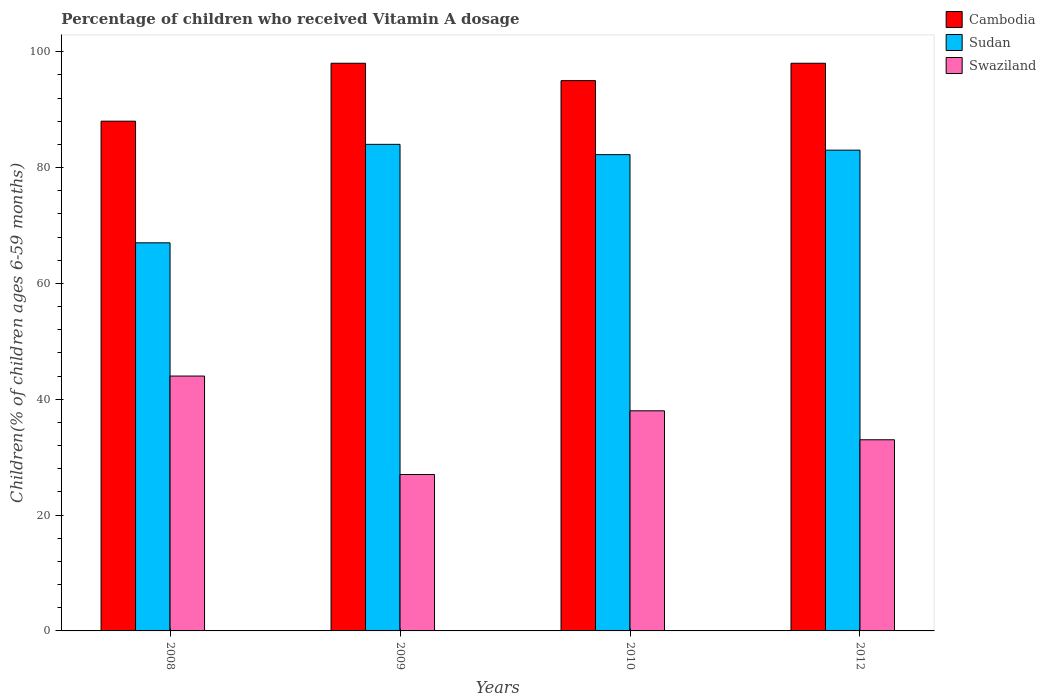How many groups of bars are there?
Keep it short and to the point. 4. Are the number of bars per tick equal to the number of legend labels?
Your answer should be compact. Yes. How many bars are there on the 4th tick from the left?
Make the answer very short. 3. What is the label of the 2nd group of bars from the left?
Offer a terse response. 2009. Across all years, what is the minimum percentage of children who received Vitamin A dosage in Sudan?
Provide a succinct answer. 67. What is the total percentage of children who received Vitamin A dosage in Cambodia in the graph?
Keep it short and to the point. 379. What is the difference between the percentage of children who received Vitamin A dosage in Sudan in 2010 and the percentage of children who received Vitamin A dosage in Cambodia in 2009?
Your response must be concise. -15.77. What is the average percentage of children who received Vitamin A dosage in Sudan per year?
Your answer should be compact. 79.06. In the year 2010, what is the difference between the percentage of children who received Vitamin A dosage in Cambodia and percentage of children who received Vitamin A dosage in Sudan?
Make the answer very short. 12.77. What is the ratio of the percentage of children who received Vitamin A dosage in Cambodia in 2008 to that in 2012?
Give a very brief answer. 0.9. Is the percentage of children who received Vitamin A dosage in Sudan in 2008 less than that in 2012?
Ensure brevity in your answer.  Yes. What is the difference between the highest and the second highest percentage of children who received Vitamin A dosage in Swaziland?
Offer a terse response. 6. Is the sum of the percentage of children who received Vitamin A dosage in Cambodia in 2008 and 2010 greater than the maximum percentage of children who received Vitamin A dosage in Swaziland across all years?
Ensure brevity in your answer.  Yes. What does the 3rd bar from the left in 2010 represents?
Ensure brevity in your answer.  Swaziland. What does the 2nd bar from the right in 2009 represents?
Your answer should be compact. Sudan. How many years are there in the graph?
Provide a short and direct response. 4. Are the values on the major ticks of Y-axis written in scientific E-notation?
Keep it short and to the point. No. What is the title of the graph?
Provide a short and direct response. Percentage of children who received Vitamin A dosage. Does "Least developed countries" appear as one of the legend labels in the graph?
Give a very brief answer. No. What is the label or title of the X-axis?
Your answer should be very brief. Years. What is the label or title of the Y-axis?
Provide a short and direct response. Children(% of children ages 6-59 months). What is the Children(% of children ages 6-59 months) in Cambodia in 2008?
Your answer should be very brief. 88. What is the Children(% of children ages 6-59 months) in Sudan in 2009?
Offer a terse response. 84. What is the Children(% of children ages 6-59 months) of Swaziland in 2009?
Make the answer very short. 27. What is the Children(% of children ages 6-59 months) of Cambodia in 2010?
Offer a very short reply. 95. What is the Children(% of children ages 6-59 months) of Sudan in 2010?
Make the answer very short. 82.23. What is the Children(% of children ages 6-59 months) in Cambodia in 2012?
Keep it short and to the point. 98. What is the Children(% of children ages 6-59 months) in Sudan in 2012?
Keep it short and to the point. 83. Across all years, what is the minimum Children(% of children ages 6-59 months) in Sudan?
Keep it short and to the point. 67. Across all years, what is the minimum Children(% of children ages 6-59 months) of Swaziland?
Your answer should be very brief. 27. What is the total Children(% of children ages 6-59 months) in Cambodia in the graph?
Offer a terse response. 379. What is the total Children(% of children ages 6-59 months) of Sudan in the graph?
Provide a succinct answer. 316.23. What is the total Children(% of children ages 6-59 months) in Swaziland in the graph?
Your response must be concise. 142. What is the difference between the Children(% of children ages 6-59 months) in Cambodia in 2008 and that in 2009?
Your answer should be compact. -10. What is the difference between the Children(% of children ages 6-59 months) in Sudan in 2008 and that in 2009?
Provide a short and direct response. -17. What is the difference between the Children(% of children ages 6-59 months) in Swaziland in 2008 and that in 2009?
Ensure brevity in your answer.  17. What is the difference between the Children(% of children ages 6-59 months) in Cambodia in 2008 and that in 2010?
Provide a short and direct response. -7. What is the difference between the Children(% of children ages 6-59 months) in Sudan in 2008 and that in 2010?
Offer a terse response. -15.23. What is the difference between the Children(% of children ages 6-59 months) in Cambodia in 2008 and that in 2012?
Your answer should be very brief. -10. What is the difference between the Children(% of children ages 6-59 months) in Sudan in 2008 and that in 2012?
Your answer should be compact. -16. What is the difference between the Children(% of children ages 6-59 months) in Swaziland in 2008 and that in 2012?
Give a very brief answer. 11. What is the difference between the Children(% of children ages 6-59 months) of Sudan in 2009 and that in 2010?
Make the answer very short. 1.77. What is the difference between the Children(% of children ages 6-59 months) in Sudan in 2009 and that in 2012?
Give a very brief answer. 1. What is the difference between the Children(% of children ages 6-59 months) in Swaziland in 2009 and that in 2012?
Keep it short and to the point. -6. What is the difference between the Children(% of children ages 6-59 months) of Sudan in 2010 and that in 2012?
Make the answer very short. -0.77. What is the difference between the Children(% of children ages 6-59 months) of Cambodia in 2008 and the Children(% of children ages 6-59 months) of Sudan in 2009?
Your response must be concise. 4. What is the difference between the Children(% of children ages 6-59 months) of Cambodia in 2008 and the Children(% of children ages 6-59 months) of Sudan in 2010?
Give a very brief answer. 5.77. What is the difference between the Children(% of children ages 6-59 months) in Cambodia in 2008 and the Children(% of children ages 6-59 months) in Swaziland in 2010?
Keep it short and to the point. 50. What is the difference between the Children(% of children ages 6-59 months) in Sudan in 2008 and the Children(% of children ages 6-59 months) in Swaziland in 2010?
Your answer should be very brief. 29. What is the difference between the Children(% of children ages 6-59 months) in Cambodia in 2008 and the Children(% of children ages 6-59 months) in Swaziland in 2012?
Provide a short and direct response. 55. What is the difference between the Children(% of children ages 6-59 months) in Cambodia in 2009 and the Children(% of children ages 6-59 months) in Sudan in 2010?
Offer a very short reply. 15.77. What is the difference between the Children(% of children ages 6-59 months) in Cambodia in 2009 and the Children(% of children ages 6-59 months) in Swaziland in 2010?
Offer a terse response. 60. What is the difference between the Children(% of children ages 6-59 months) of Sudan in 2009 and the Children(% of children ages 6-59 months) of Swaziland in 2010?
Offer a very short reply. 46. What is the difference between the Children(% of children ages 6-59 months) of Cambodia in 2009 and the Children(% of children ages 6-59 months) of Sudan in 2012?
Give a very brief answer. 15. What is the difference between the Children(% of children ages 6-59 months) in Cambodia in 2010 and the Children(% of children ages 6-59 months) in Sudan in 2012?
Make the answer very short. 12. What is the difference between the Children(% of children ages 6-59 months) in Sudan in 2010 and the Children(% of children ages 6-59 months) in Swaziland in 2012?
Offer a very short reply. 49.23. What is the average Children(% of children ages 6-59 months) of Cambodia per year?
Your answer should be very brief. 94.75. What is the average Children(% of children ages 6-59 months) in Sudan per year?
Ensure brevity in your answer.  79.06. What is the average Children(% of children ages 6-59 months) in Swaziland per year?
Your answer should be very brief. 35.5. In the year 2008, what is the difference between the Children(% of children ages 6-59 months) in Cambodia and Children(% of children ages 6-59 months) in Sudan?
Give a very brief answer. 21. In the year 2010, what is the difference between the Children(% of children ages 6-59 months) in Cambodia and Children(% of children ages 6-59 months) in Sudan?
Provide a succinct answer. 12.77. In the year 2010, what is the difference between the Children(% of children ages 6-59 months) of Sudan and Children(% of children ages 6-59 months) of Swaziland?
Your answer should be compact. 44.23. In the year 2012, what is the difference between the Children(% of children ages 6-59 months) of Cambodia and Children(% of children ages 6-59 months) of Sudan?
Make the answer very short. 15. In the year 2012, what is the difference between the Children(% of children ages 6-59 months) of Cambodia and Children(% of children ages 6-59 months) of Swaziland?
Your answer should be very brief. 65. In the year 2012, what is the difference between the Children(% of children ages 6-59 months) of Sudan and Children(% of children ages 6-59 months) of Swaziland?
Provide a short and direct response. 50. What is the ratio of the Children(% of children ages 6-59 months) in Cambodia in 2008 to that in 2009?
Ensure brevity in your answer.  0.9. What is the ratio of the Children(% of children ages 6-59 months) in Sudan in 2008 to that in 2009?
Your response must be concise. 0.8. What is the ratio of the Children(% of children ages 6-59 months) of Swaziland in 2008 to that in 2009?
Provide a succinct answer. 1.63. What is the ratio of the Children(% of children ages 6-59 months) in Cambodia in 2008 to that in 2010?
Your answer should be compact. 0.93. What is the ratio of the Children(% of children ages 6-59 months) of Sudan in 2008 to that in 2010?
Keep it short and to the point. 0.81. What is the ratio of the Children(% of children ages 6-59 months) of Swaziland in 2008 to that in 2010?
Keep it short and to the point. 1.16. What is the ratio of the Children(% of children ages 6-59 months) in Cambodia in 2008 to that in 2012?
Offer a very short reply. 0.9. What is the ratio of the Children(% of children ages 6-59 months) in Sudan in 2008 to that in 2012?
Ensure brevity in your answer.  0.81. What is the ratio of the Children(% of children ages 6-59 months) in Swaziland in 2008 to that in 2012?
Offer a terse response. 1.33. What is the ratio of the Children(% of children ages 6-59 months) of Cambodia in 2009 to that in 2010?
Make the answer very short. 1.03. What is the ratio of the Children(% of children ages 6-59 months) of Sudan in 2009 to that in 2010?
Your answer should be compact. 1.02. What is the ratio of the Children(% of children ages 6-59 months) of Swaziland in 2009 to that in 2010?
Keep it short and to the point. 0.71. What is the ratio of the Children(% of children ages 6-59 months) in Swaziland in 2009 to that in 2012?
Your answer should be very brief. 0.82. What is the ratio of the Children(% of children ages 6-59 months) in Cambodia in 2010 to that in 2012?
Your answer should be very brief. 0.97. What is the ratio of the Children(% of children ages 6-59 months) in Sudan in 2010 to that in 2012?
Your answer should be compact. 0.99. What is the ratio of the Children(% of children ages 6-59 months) of Swaziland in 2010 to that in 2012?
Provide a succinct answer. 1.15. What is the difference between the highest and the second highest Children(% of children ages 6-59 months) in Cambodia?
Offer a very short reply. 0. What is the difference between the highest and the lowest Children(% of children ages 6-59 months) of Swaziland?
Your answer should be compact. 17. 